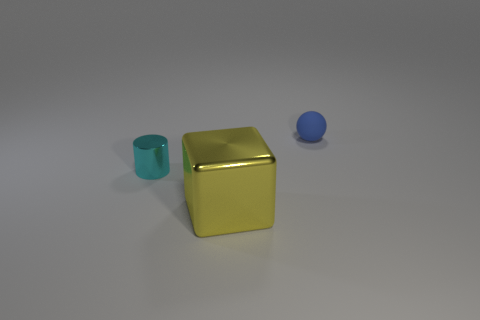There is a large yellow block; what number of big yellow metallic cubes are to the right of it?
Keep it short and to the point. 0. Are the small blue sphere and the big yellow thing made of the same material?
Offer a very short reply. No. What number of metallic things are in front of the cyan cylinder and left of the large metallic cube?
Provide a succinct answer. 0. What number of other things are the same color as the cube?
Make the answer very short. 0. How many yellow objects are tiny rubber balls or cubes?
Provide a short and direct response. 1. What is the size of the yellow metal object?
Ensure brevity in your answer.  Large. How many rubber objects are big cubes or green balls?
Your response must be concise. 0. Are there fewer yellow shiny cubes than objects?
Your response must be concise. Yes. How many other objects are the same material as the cyan thing?
Your response must be concise. 1. Is the material of the object to the left of the large cube the same as the thing that is behind the cyan cylinder?
Your answer should be compact. No. 